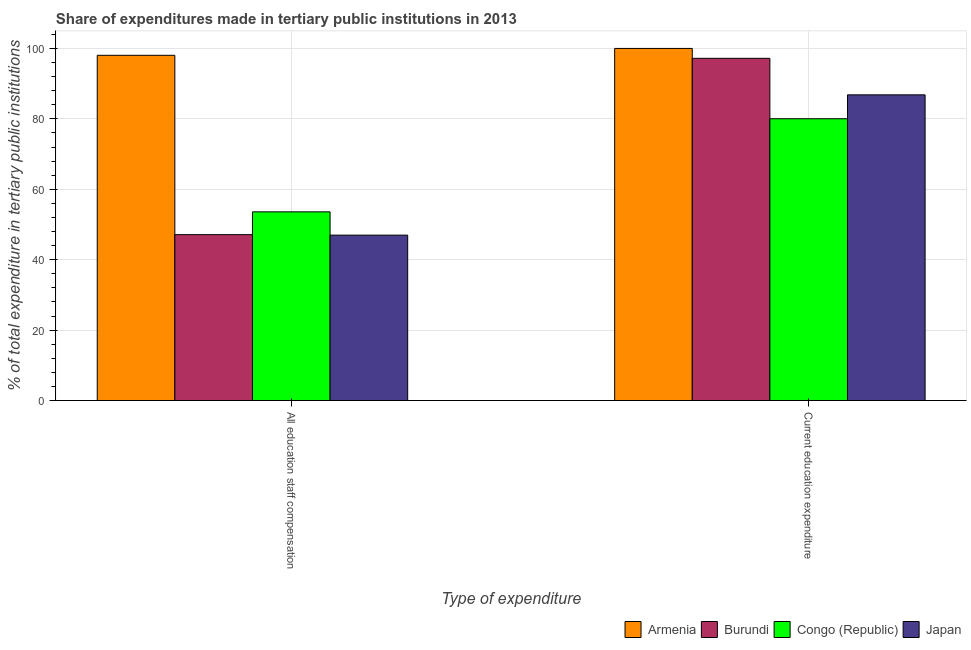How many different coloured bars are there?
Offer a terse response. 4. Are the number of bars on each tick of the X-axis equal?
Give a very brief answer. Yes. What is the label of the 1st group of bars from the left?
Your response must be concise. All education staff compensation. What is the expenditure in education in Congo (Republic)?
Your answer should be very brief. 80.04. Across all countries, what is the minimum expenditure in education?
Make the answer very short. 80.04. In which country was the expenditure in staff compensation maximum?
Your response must be concise. Armenia. In which country was the expenditure in education minimum?
Keep it short and to the point. Congo (Republic). What is the total expenditure in education in the graph?
Make the answer very short. 364.05. What is the difference between the expenditure in education in Japan and that in Armenia?
Keep it short and to the point. -13.18. What is the difference between the expenditure in education in Armenia and the expenditure in staff compensation in Burundi?
Keep it short and to the point. 52.88. What is the average expenditure in education per country?
Keep it short and to the point. 91.01. What is the difference between the expenditure in staff compensation and expenditure in education in Burundi?
Offer a very short reply. -50.07. What is the ratio of the expenditure in education in Burundi to that in Japan?
Provide a short and direct response. 1.12. Is the expenditure in education in Congo (Republic) less than that in Japan?
Your response must be concise. Yes. In how many countries, is the expenditure in staff compensation greater than the average expenditure in staff compensation taken over all countries?
Keep it short and to the point. 1. What does the 3rd bar from the left in Current education expenditure represents?
Provide a short and direct response. Congo (Republic). What does the 2nd bar from the right in Current education expenditure represents?
Keep it short and to the point. Congo (Republic). Does the graph contain grids?
Your response must be concise. Yes. How are the legend labels stacked?
Offer a very short reply. Horizontal. What is the title of the graph?
Make the answer very short. Share of expenditures made in tertiary public institutions in 2013. What is the label or title of the X-axis?
Offer a very short reply. Type of expenditure. What is the label or title of the Y-axis?
Keep it short and to the point. % of total expenditure in tertiary public institutions. What is the % of total expenditure in tertiary public institutions in Armenia in All education staff compensation?
Your answer should be compact. 98.05. What is the % of total expenditure in tertiary public institutions of Burundi in All education staff compensation?
Offer a terse response. 47.12. What is the % of total expenditure in tertiary public institutions of Congo (Republic) in All education staff compensation?
Ensure brevity in your answer.  53.59. What is the % of total expenditure in tertiary public institutions in Japan in All education staff compensation?
Give a very brief answer. 46.98. What is the % of total expenditure in tertiary public institutions of Armenia in Current education expenditure?
Make the answer very short. 100. What is the % of total expenditure in tertiary public institutions of Burundi in Current education expenditure?
Provide a succinct answer. 97.19. What is the % of total expenditure in tertiary public institutions of Congo (Republic) in Current education expenditure?
Your answer should be very brief. 80.04. What is the % of total expenditure in tertiary public institutions of Japan in Current education expenditure?
Keep it short and to the point. 86.82. Across all Type of expenditure, what is the maximum % of total expenditure in tertiary public institutions in Burundi?
Your answer should be very brief. 97.19. Across all Type of expenditure, what is the maximum % of total expenditure in tertiary public institutions in Congo (Republic)?
Offer a terse response. 80.04. Across all Type of expenditure, what is the maximum % of total expenditure in tertiary public institutions of Japan?
Your response must be concise. 86.82. Across all Type of expenditure, what is the minimum % of total expenditure in tertiary public institutions in Armenia?
Ensure brevity in your answer.  98.05. Across all Type of expenditure, what is the minimum % of total expenditure in tertiary public institutions of Burundi?
Your answer should be compact. 47.12. Across all Type of expenditure, what is the minimum % of total expenditure in tertiary public institutions in Congo (Republic)?
Your answer should be very brief. 53.59. Across all Type of expenditure, what is the minimum % of total expenditure in tertiary public institutions of Japan?
Give a very brief answer. 46.98. What is the total % of total expenditure in tertiary public institutions in Armenia in the graph?
Offer a terse response. 198.05. What is the total % of total expenditure in tertiary public institutions in Burundi in the graph?
Your response must be concise. 144.31. What is the total % of total expenditure in tertiary public institutions in Congo (Republic) in the graph?
Offer a very short reply. 133.63. What is the total % of total expenditure in tertiary public institutions in Japan in the graph?
Ensure brevity in your answer.  133.8. What is the difference between the % of total expenditure in tertiary public institutions of Armenia in All education staff compensation and that in Current education expenditure?
Your answer should be compact. -1.95. What is the difference between the % of total expenditure in tertiary public institutions in Burundi in All education staff compensation and that in Current education expenditure?
Your response must be concise. -50.07. What is the difference between the % of total expenditure in tertiary public institutions in Congo (Republic) in All education staff compensation and that in Current education expenditure?
Keep it short and to the point. -26.44. What is the difference between the % of total expenditure in tertiary public institutions of Japan in All education staff compensation and that in Current education expenditure?
Ensure brevity in your answer.  -39.84. What is the difference between the % of total expenditure in tertiary public institutions in Armenia in All education staff compensation and the % of total expenditure in tertiary public institutions in Burundi in Current education expenditure?
Provide a short and direct response. 0.86. What is the difference between the % of total expenditure in tertiary public institutions in Armenia in All education staff compensation and the % of total expenditure in tertiary public institutions in Congo (Republic) in Current education expenditure?
Ensure brevity in your answer.  18.01. What is the difference between the % of total expenditure in tertiary public institutions of Armenia in All education staff compensation and the % of total expenditure in tertiary public institutions of Japan in Current education expenditure?
Ensure brevity in your answer.  11.23. What is the difference between the % of total expenditure in tertiary public institutions in Burundi in All education staff compensation and the % of total expenditure in tertiary public institutions in Congo (Republic) in Current education expenditure?
Provide a succinct answer. -32.92. What is the difference between the % of total expenditure in tertiary public institutions of Burundi in All education staff compensation and the % of total expenditure in tertiary public institutions of Japan in Current education expenditure?
Your answer should be very brief. -39.7. What is the difference between the % of total expenditure in tertiary public institutions of Congo (Republic) in All education staff compensation and the % of total expenditure in tertiary public institutions of Japan in Current education expenditure?
Your response must be concise. -33.23. What is the average % of total expenditure in tertiary public institutions in Armenia per Type of expenditure?
Make the answer very short. 99.03. What is the average % of total expenditure in tertiary public institutions of Burundi per Type of expenditure?
Offer a terse response. 72.15. What is the average % of total expenditure in tertiary public institutions in Congo (Republic) per Type of expenditure?
Ensure brevity in your answer.  66.81. What is the average % of total expenditure in tertiary public institutions of Japan per Type of expenditure?
Give a very brief answer. 66.9. What is the difference between the % of total expenditure in tertiary public institutions in Armenia and % of total expenditure in tertiary public institutions in Burundi in All education staff compensation?
Make the answer very short. 50.93. What is the difference between the % of total expenditure in tertiary public institutions in Armenia and % of total expenditure in tertiary public institutions in Congo (Republic) in All education staff compensation?
Your answer should be very brief. 44.46. What is the difference between the % of total expenditure in tertiary public institutions in Armenia and % of total expenditure in tertiary public institutions in Japan in All education staff compensation?
Your answer should be very brief. 51.07. What is the difference between the % of total expenditure in tertiary public institutions in Burundi and % of total expenditure in tertiary public institutions in Congo (Republic) in All education staff compensation?
Your response must be concise. -6.48. What is the difference between the % of total expenditure in tertiary public institutions of Burundi and % of total expenditure in tertiary public institutions of Japan in All education staff compensation?
Your answer should be very brief. 0.13. What is the difference between the % of total expenditure in tertiary public institutions of Congo (Republic) and % of total expenditure in tertiary public institutions of Japan in All education staff compensation?
Your answer should be compact. 6.61. What is the difference between the % of total expenditure in tertiary public institutions of Armenia and % of total expenditure in tertiary public institutions of Burundi in Current education expenditure?
Offer a terse response. 2.81. What is the difference between the % of total expenditure in tertiary public institutions of Armenia and % of total expenditure in tertiary public institutions of Congo (Republic) in Current education expenditure?
Keep it short and to the point. 19.96. What is the difference between the % of total expenditure in tertiary public institutions of Armenia and % of total expenditure in tertiary public institutions of Japan in Current education expenditure?
Your response must be concise. 13.18. What is the difference between the % of total expenditure in tertiary public institutions of Burundi and % of total expenditure in tertiary public institutions of Congo (Republic) in Current education expenditure?
Offer a very short reply. 17.16. What is the difference between the % of total expenditure in tertiary public institutions of Burundi and % of total expenditure in tertiary public institutions of Japan in Current education expenditure?
Offer a very short reply. 10.37. What is the difference between the % of total expenditure in tertiary public institutions in Congo (Republic) and % of total expenditure in tertiary public institutions in Japan in Current education expenditure?
Your response must be concise. -6.79. What is the ratio of the % of total expenditure in tertiary public institutions of Armenia in All education staff compensation to that in Current education expenditure?
Your answer should be compact. 0.98. What is the ratio of the % of total expenditure in tertiary public institutions of Burundi in All education staff compensation to that in Current education expenditure?
Offer a very short reply. 0.48. What is the ratio of the % of total expenditure in tertiary public institutions of Congo (Republic) in All education staff compensation to that in Current education expenditure?
Your answer should be very brief. 0.67. What is the ratio of the % of total expenditure in tertiary public institutions of Japan in All education staff compensation to that in Current education expenditure?
Give a very brief answer. 0.54. What is the difference between the highest and the second highest % of total expenditure in tertiary public institutions in Armenia?
Give a very brief answer. 1.95. What is the difference between the highest and the second highest % of total expenditure in tertiary public institutions of Burundi?
Give a very brief answer. 50.07. What is the difference between the highest and the second highest % of total expenditure in tertiary public institutions in Congo (Republic)?
Your response must be concise. 26.44. What is the difference between the highest and the second highest % of total expenditure in tertiary public institutions in Japan?
Offer a terse response. 39.84. What is the difference between the highest and the lowest % of total expenditure in tertiary public institutions in Armenia?
Provide a succinct answer. 1.95. What is the difference between the highest and the lowest % of total expenditure in tertiary public institutions in Burundi?
Give a very brief answer. 50.07. What is the difference between the highest and the lowest % of total expenditure in tertiary public institutions in Congo (Republic)?
Your answer should be compact. 26.44. What is the difference between the highest and the lowest % of total expenditure in tertiary public institutions of Japan?
Give a very brief answer. 39.84. 